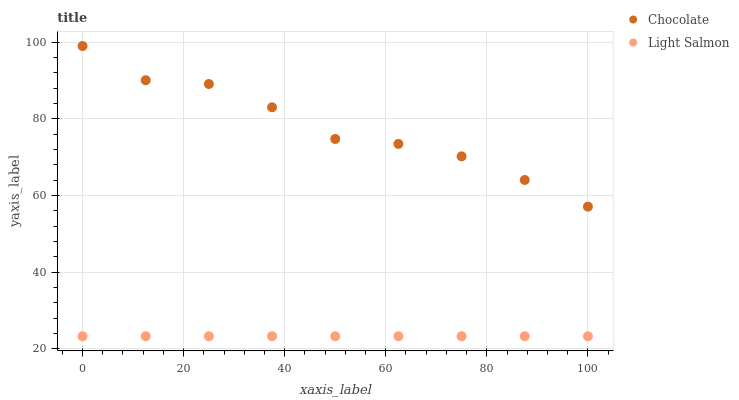Does Light Salmon have the minimum area under the curve?
Answer yes or no. Yes. Does Chocolate have the maximum area under the curve?
Answer yes or no. Yes. Does Chocolate have the minimum area under the curve?
Answer yes or no. No. Is Light Salmon the smoothest?
Answer yes or no. Yes. Is Chocolate the roughest?
Answer yes or no. Yes. Is Chocolate the smoothest?
Answer yes or no. No. Does Light Salmon have the lowest value?
Answer yes or no. Yes. Does Chocolate have the lowest value?
Answer yes or no. No. Does Chocolate have the highest value?
Answer yes or no. Yes. Is Light Salmon less than Chocolate?
Answer yes or no. Yes. Is Chocolate greater than Light Salmon?
Answer yes or no. Yes. Does Light Salmon intersect Chocolate?
Answer yes or no. No. 